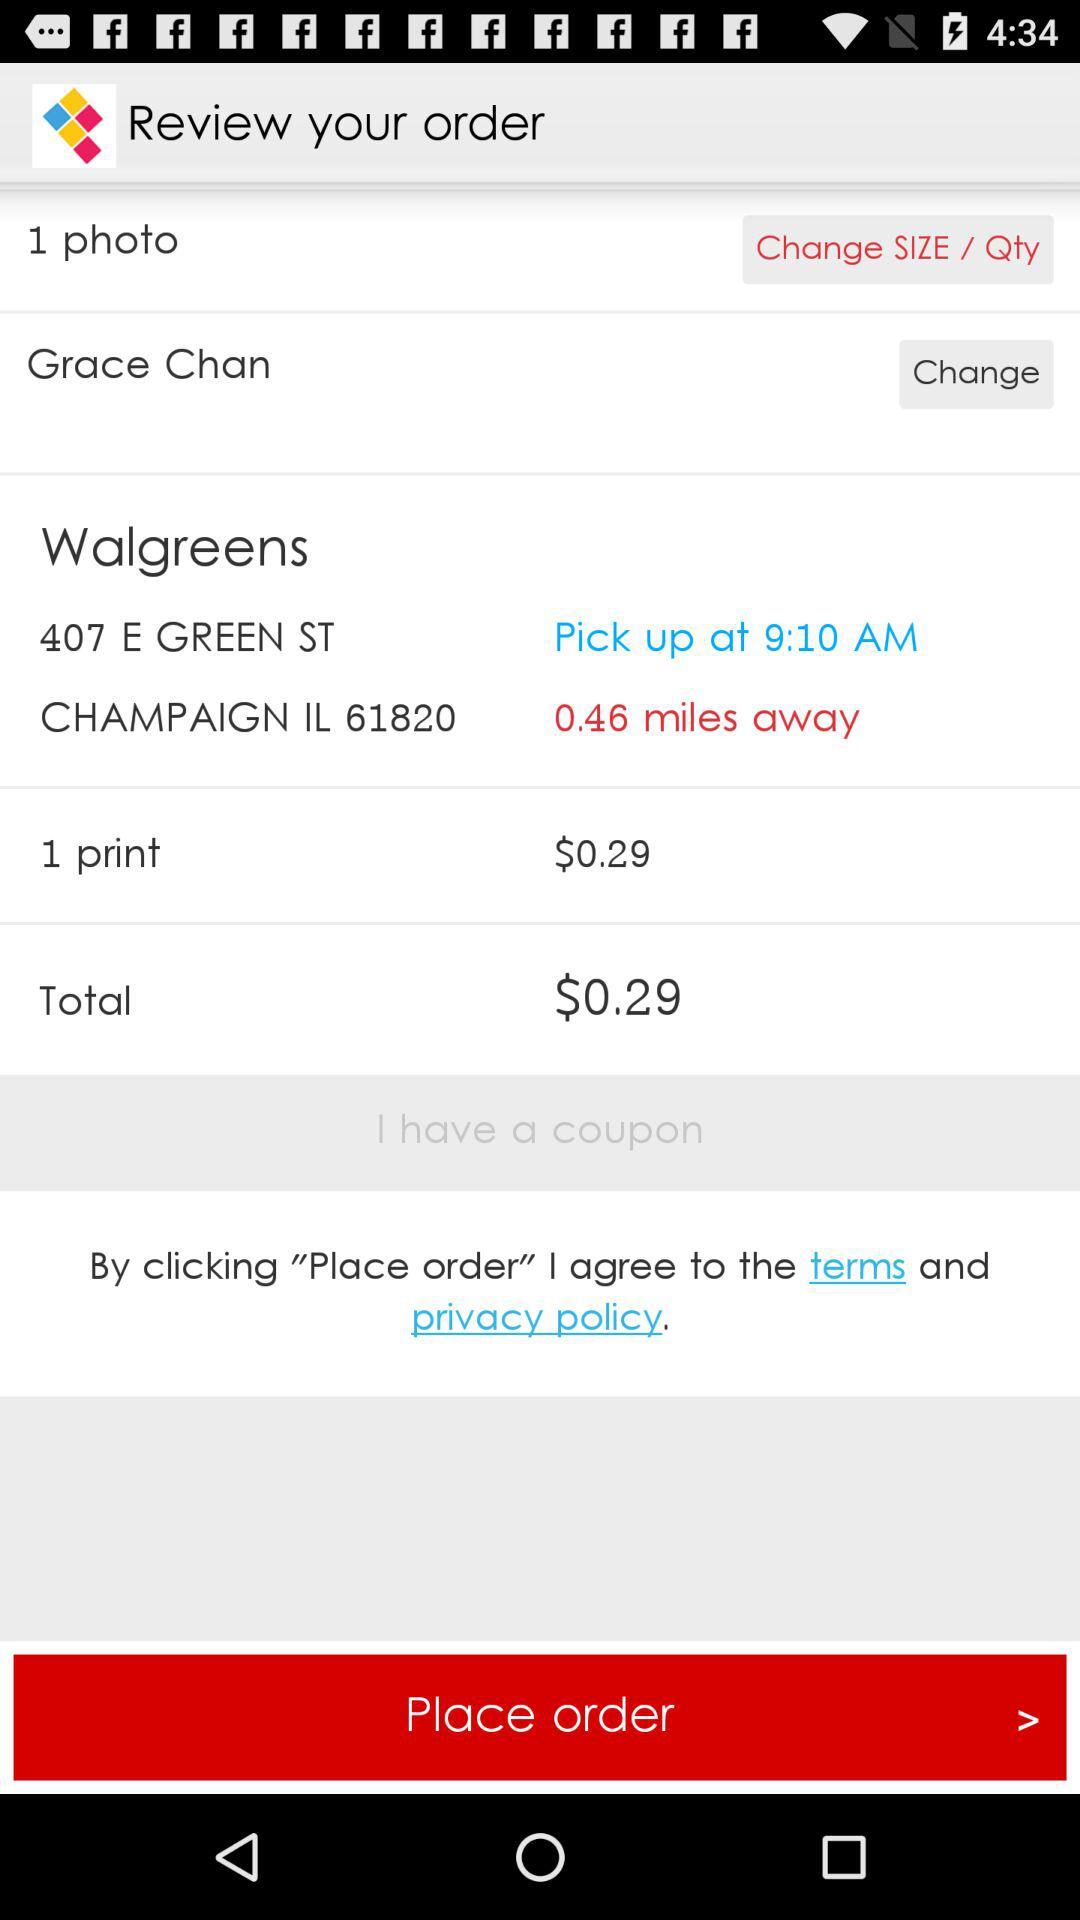What is the pick up time? The pick up time is 9:10 AM. 